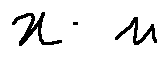<formula> <loc_0><loc_0><loc_500><loc_500>x - n</formula> 